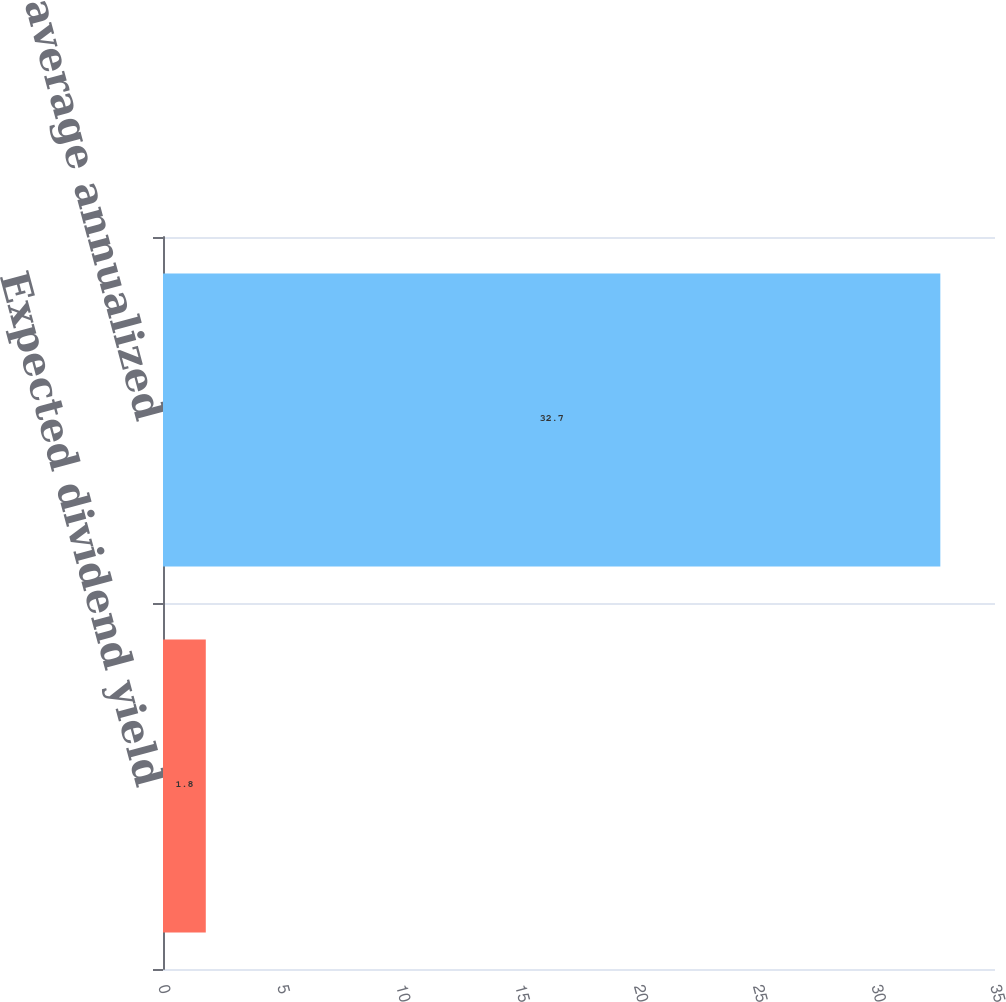Convert chart to OTSL. <chart><loc_0><loc_0><loc_500><loc_500><bar_chart><fcel>Expected dividend yield<fcel>Weighted average annualized<nl><fcel>1.8<fcel>32.7<nl></chart> 